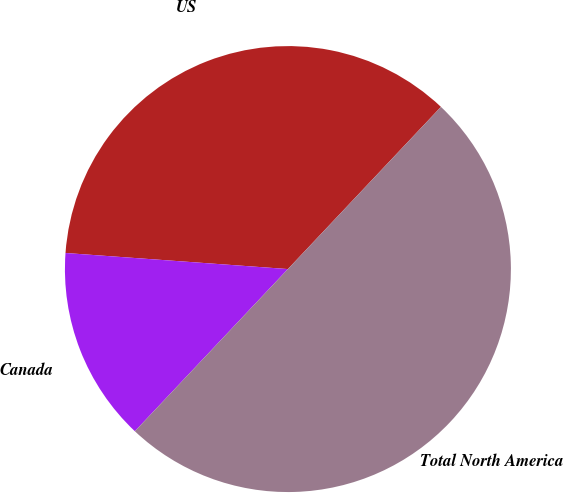Convert chart. <chart><loc_0><loc_0><loc_500><loc_500><pie_chart><fcel>US<fcel>Canada<fcel>Total North America<nl><fcel>35.89%<fcel>14.11%<fcel>50.0%<nl></chart> 